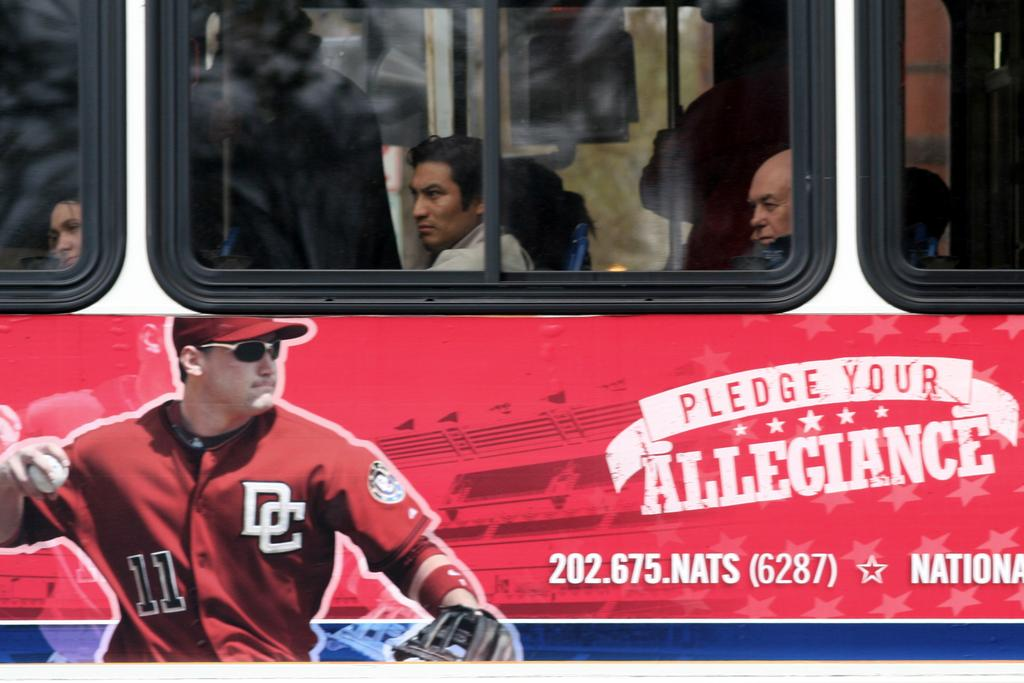Provide a one-sentence caption for the provided image. The side of a bus that is advertsing the baseball team from D.C. 